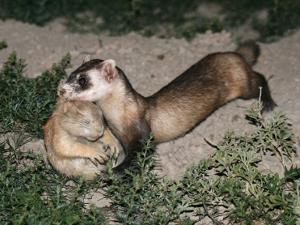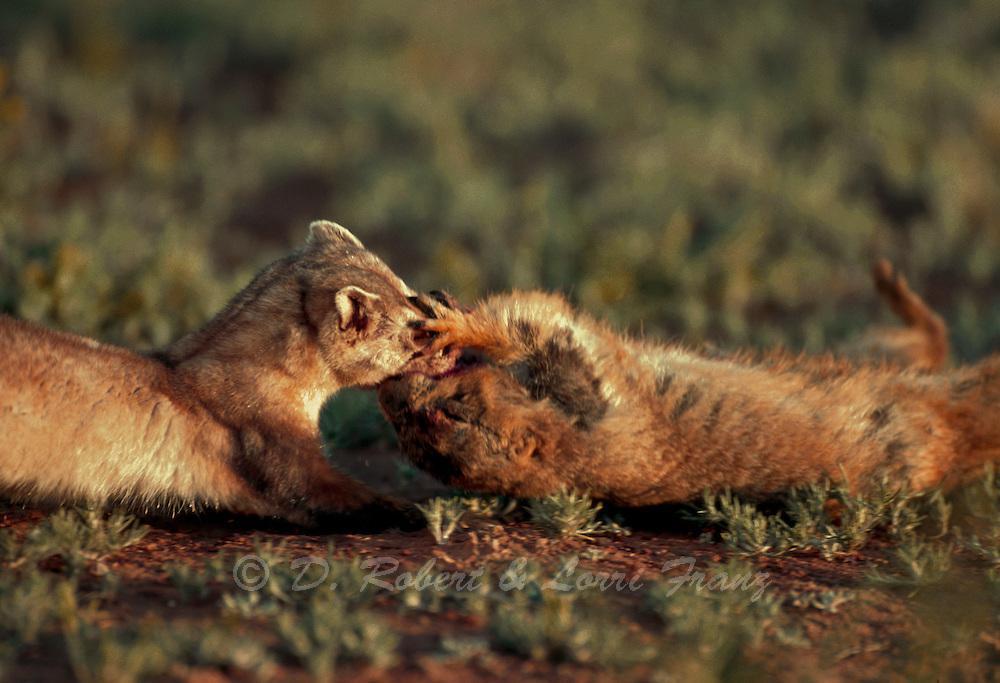The first image is the image on the left, the second image is the image on the right. For the images displayed, is the sentence "There are exactly two ferrets." factually correct? Answer yes or no. No. 